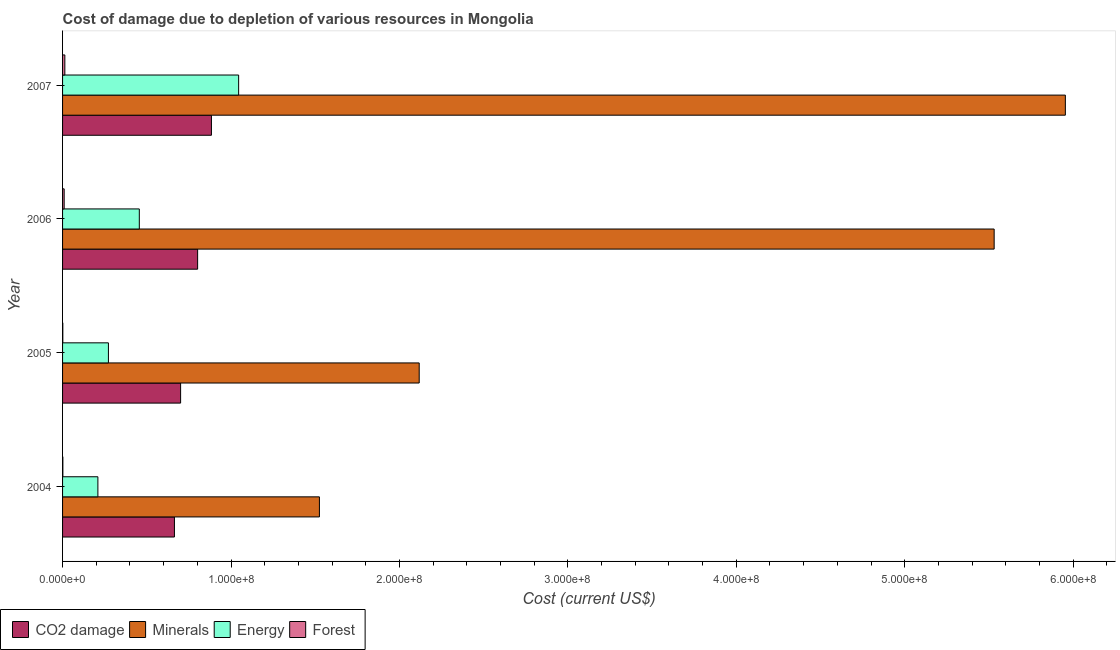How many different coloured bars are there?
Give a very brief answer. 4. Are the number of bars per tick equal to the number of legend labels?
Your response must be concise. Yes. Are the number of bars on each tick of the Y-axis equal?
Ensure brevity in your answer.  Yes. What is the cost of damage due to depletion of energy in 2004?
Provide a short and direct response. 2.10e+07. Across all years, what is the maximum cost of damage due to depletion of coal?
Provide a succinct answer. 8.84e+07. Across all years, what is the minimum cost of damage due to depletion of coal?
Provide a succinct answer. 6.64e+07. In which year was the cost of damage due to depletion of coal minimum?
Ensure brevity in your answer.  2004. What is the total cost of damage due to depletion of energy in the graph?
Offer a very short reply. 1.98e+08. What is the difference between the cost of damage due to depletion of minerals in 2005 and that in 2007?
Make the answer very short. -3.84e+08. What is the difference between the cost of damage due to depletion of minerals in 2007 and the cost of damage due to depletion of energy in 2006?
Your answer should be very brief. 5.50e+08. What is the average cost of damage due to depletion of coal per year?
Your answer should be compact. 7.63e+07. In the year 2004, what is the difference between the cost of damage due to depletion of energy and cost of damage due to depletion of minerals?
Give a very brief answer. -1.32e+08. In how many years, is the cost of damage due to depletion of minerals greater than 320000000 US$?
Make the answer very short. 2. What is the ratio of the cost of damage due to depletion of forests in 2004 to that in 2006?
Give a very brief answer. 0.19. Is the cost of damage due to depletion of forests in 2004 less than that in 2005?
Keep it short and to the point. No. Is the difference between the cost of damage due to depletion of minerals in 2004 and 2007 greater than the difference between the cost of damage due to depletion of energy in 2004 and 2007?
Give a very brief answer. No. What is the difference between the highest and the second highest cost of damage due to depletion of coal?
Provide a succinct answer. 8.20e+06. What is the difference between the highest and the lowest cost of damage due to depletion of energy?
Your answer should be very brief. 8.36e+07. In how many years, is the cost of damage due to depletion of energy greater than the average cost of damage due to depletion of energy taken over all years?
Offer a terse response. 1. What does the 3rd bar from the top in 2007 represents?
Ensure brevity in your answer.  Minerals. What does the 3rd bar from the bottom in 2005 represents?
Your answer should be very brief. Energy. How many years are there in the graph?
Offer a terse response. 4. Does the graph contain any zero values?
Your answer should be very brief. No. Where does the legend appear in the graph?
Your answer should be compact. Bottom left. How many legend labels are there?
Your response must be concise. 4. What is the title of the graph?
Provide a succinct answer. Cost of damage due to depletion of various resources in Mongolia . Does "Coal" appear as one of the legend labels in the graph?
Your answer should be compact. No. What is the label or title of the X-axis?
Keep it short and to the point. Cost (current US$). What is the Cost (current US$) of CO2 damage in 2004?
Offer a very short reply. 6.64e+07. What is the Cost (current US$) of Minerals in 2004?
Offer a very short reply. 1.53e+08. What is the Cost (current US$) of Energy in 2004?
Keep it short and to the point. 2.10e+07. What is the Cost (current US$) of Forest in 2004?
Keep it short and to the point. 1.76e+05. What is the Cost (current US$) in CO2 damage in 2005?
Ensure brevity in your answer.  7.01e+07. What is the Cost (current US$) of Minerals in 2005?
Give a very brief answer. 2.12e+08. What is the Cost (current US$) in Energy in 2005?
Your answer should be very brief. 2.72e+07. What is the Cost (current US$) of Forest in 2005?
Keep it short and to the point. 1.45e+05. What is the Cost (current US$) of CO2 damage in 2006?
Provide a succinct answer. 8.02e+07. What is the Cost (current US$) in Minerals in 2006?
Provide a short and direct response. 5.53e+08. What is the Cost (current US$) in Energy in 2006?
Provide a short and direct response. 4.56e+07. What is the Cost (current US$) in Forest in 2006?
Provide a short and direct response. 9.49e+05. What is the Cost (current US$) of CO2 damage in 2007?
Provide a short and direct response. 8.84e+07. What is the Cost (current US$) in Minerals in 2007?
Make the answer very short. 5.95e+08. What is the Cost (current US$) in Energy in 2007?
Make the answer very short. 1.05e+08. What is the Cost (current US$) in Forest in 2007?
Keep it short and to the point. 1.35e+06. Across all years, what is the maximum Cost (current US$) of CO2 damage?
Your response must be concise. 8.84e+07. Across all years, what is the maximum Cost (current US$) of Minerals?
Provide a succinct answer. 5.95e+08. Across all years, what is the maximum Cost (current US$) of Energy?
Provide a short and direct response. 1.05e+08. Across all years, what is the maximum Cost (current US$) of Forest?
Your response must be concise. 1.35e+06. Across all years, what is the minimum Cost (current US$) of CO2 damage?
Your answer should be compact. 6.64e+07. Across all years, what is the minimum Cost (current US$) of Minerals?
Ensure brevity in your answer.  1.53e+08. Across all years, what is the minimum Cost (current US$) in Energy?
Ensure brevity in your answer.  2.10e+07. Across all years, what is the minimum Cost (current US$) of Forest?
Keep it short and to the point. 1.45e+05. What is the total Cost (current US$) in CO2 damage in the graph?
Make the answer very short. 3.05e+08. What is the total Cost (current US$) in Minerals in the graph?
Offer a terse response. 1.51e+09. What is the total Cost (current US$) in Energy in the graph?
Give a very brief answer. 1.98e+08. What is the total Cost (current US$) in Forest in the graph?
Provide a short and direct response. 2.62e+06. What is the difference between the Cost (current US$) of CO2 damage in 2004 and that in 2005?
Ensure brevity in your answer.  -3.67e+06. What is the difference between the Cost (current US$) in Minerals in 2004 and that in 2005?
Offer a very short reply. -5.92e+07. What is the difference between the Cost (current US$) in Energy in 2004 and that in 2005?
Your answer should be very brief. -6.25e+06. What is the difference between the Cost (current US$) of Forest in 2004 and that in 2005?
Ensure brevity in your answer.  3.19e+04. What is the difference between the Cost (current US$) in CO2 damage in 2004 and that in 2006?
Keep it short and to the point. -1.38e+07. What is the difference between the Cost (current US$) in Minerals in 2004 and that in 2006?
Ensure brevity in your answer.  -4.01e+08. What is the difference between the Cost (current US$) in Energy in 2004 and that in 2006?
Your response must be concise. -2.46e+07. What is the difference between the Cost (current US$) in Forest in 2004 and that in 2006?
Keep it short and to the point. -7.73e+05. What is the difference between the Cost (current US$) of CO2 damage in 2004 and that in 2007?
Give a very brief answer. -2.20e+07. What is the difference between the Cost (current US$) in Minerals in 2004 and that in 2007?
Provide a short and direct response. -4.43e+08. What is the difference between the Cost (current US$) in Energy in 2004 and that in 2007?
Ensure brevity in your answer.  -8.36e+07. What is the difference between the Cost (current US$) of Forest in 2004 and that in 2007?
Your response must be concise. -1.18e+06. What is the difference between the Cost (current US$) in CO2 damage in 2005 and that in 2006?
Ensure brevity in your answer.  -1.01e+07. What is the difference between the Cost (current US$) of Minerals in 2005 and that in 2006?
Your answer should be very brief. -3.41e+08. What is the difference between the Cost (current US$) in Energy in 2005 and that in 2006?
Provide a short and direct response. -1.83e+07. What is the difference between the Cost (current US$) in Forest in 2005 and that in 2006?
Give a very brief answer. -8.05e+05. What is the difference between the Cost (current US$) of CO2 damage in 2005 and that in 2007?
Provide a succinct answer. -1.83e+07. What is the difference between the Cost (current US$) in Minerals in 2005 and that in 2007?
Provide a short and direct response. -3.84e+08. What is the difference between the Cost (current US$) in Energy in 2005 and that in 2007?
Keep it short and to the point. -7.73e+07. What is the difference between the Cost (current US$) of Forest in 2005 and that in 2007?
Offer a very short reply. -1.21e+06. What is the difference between the Cost (current US$) of CO2 damage in 2006 and that in 2007?
Ensure brevity in your answer.  -8.20e+06. What is the difference between the Cost (current US$) of Minerals in 2006 and that in 2007?
Offer a very short reply. -4.23e+07. What is the difference between the Cost (current US$) of Energy in 2006 and that in 2007?
Provide a short and direct response. -5.90e+07. What is the difference between the Cost (current US$) of Forest in 2006 and that in 2007?
Provide a succinct answer. -4.04e+05. What is the difference between the Cost (current US$) in CO2 damage in 2004 and the Cost (current US$) in Minerals in 2005?
Offer a very short reply. -1.45e+08. What is the difference between the Cost (current US$) of CO2 damage in 2004 and the Cost (current US$) of Energy in 2005?
Provide a short and direct response. 3.92e+07. What is the difference between the Cost (current US$) of CO2 damage in 2004 and the Cost (current US$) of Forest in 2005?
Ensure brevity in your answer.  6.63e+07. What is the difference between the Cost (current US$) of Minerals in 2004 and the Cost (current US$) of Energy in 2005?
Offer a very short reply. 1.25e+08. What is the difference between the Cost (current US$) of Minerals in 2004 and the Cost (current US$) of Forest in 2005?
Make the answer very short. 1.52e+08. What is the difference between the Cost (current US$) in Energy in 2004 and the Cost (current US$) in Forest in 2005?
Ensure brevity in your answer.  2.08e+07. What is the difference between the Cost (current US$) in CO2 damage in 2004 and the Cost (current US$) in Minerals in 2006?
Your response must be concise. -4.87e+08. What is the difference between the Cost (current US$) of CO2 damage in 2004 and the Cost (current US$) of Energy in 2006?
Ensure brevity in your answer.  2.08e+07. What is the difference between the Cost (current US$) in CO2 damage in 2004 and the Cost (current US$) in Forest in 2006?
Provide a succinct answer. 6.55e+07. What is the difference between the Cost (current US$) of Minerals in 2004 and the Cost (current US$) of Energy in 2006?
Offer a terse response. 1.07e+08. What is the difference between the Cost (current US$) of Minerals in 2004 and the Cost (current US$) of Forest in 2006?
Your answer should be very brief. 1.52e+08. What is the difference between the Cost (current US$) of Energy in 2004 and the Cost (current US$) of Forest in 2006?
Your answer should be compact. 2.00e+07. What is the difference between the Cost (current US$) of CO2 damage in 2004 and the Cost (current US$) of Minerals in 2007?
Offer a terse response. -5.29e+08. What is the difference between the Cost (current US$) in CO2 damage in 2004 and the Cost (current US$) in Energy in 2007?
Provide a short and direct response. -3.81e+07. What is the difference between the Cost (current US$) of CO2 damage in 2004 and the Cost (current US$) of Forest in 2007?
Ensure brevity in your answer.  6.51e+07. What is the difference between the Cost (current US$) in Minerals in 2004 and the Cost (current US$) in Energy in 2007?
Offer a terse response. 4.80e+07. What is the difference between the Cost (current US$) in Minerals in 2004 and the Cost (current US$) in Forest in 2007?
Keep it short and to the point. 1.51e+08. What is the difference between the Cost (current US$) of Energy in 2004 and the Cost (current US$) of Forest in 2007?
Provide a succinct answer. 1.96e+07. What is the difference between the Cost (current US$) of CO2 damage in 2005 and the Cost (current US$) of Minerals in 2006?
Your answer should be very brief. -4.83e+08. What is the difference between the Cost (current US$) in CO2 damage in 2005 and the Cost (current US$) in Energy in 2006?
Make the answer very short. 2.45e+07. What is the difference between the Cost (current US$) in CO2 damage in 2005 and the Cost (current US$) in Forest in 2006?
Ensure brevity in your answer.  6.91e+07. What is the difference between the Cost (current US$) of Minerals in 2005 and the Cost (current US$) of Energy in 2006?
Make the answer very short. 1.66e+08. What is the difference between the Cost (current US$) in Minerals in 2005 and the Cost (current US$) in Forest in 2006?
Provide a succinct answer. 2.11e+08. What is the difference between the Cost (current US$) of Energy in 2005 and the Cost (current US$) of Forest in 2006?
Provide a succinct answer. 2.63e+07. What is the difference between the Cost (current US$) of CO2 damage in 2005 and the Cost (current US$) of Minerals in 2007?
Give a very brief answer. -5.25e+08. What is the difference between the Cost (current US$) of CO2 damage in 2005 and the Cost (current US$) of Energy in 2007?
Provide a short and direct response. -3.44e+07. What is the difference between the Cost (current US$) of CO2 damage in 2005 and the Cost (current US$) of Forest in 2007?
Your answer should be compact. 6.87e+07. What is the difference between the Cost (current US$) of Minerals in 2005 and the Cost (current US$) of Energy in 2007?
Offer a very short reply. 1.07e+08. What is the difference between the Cost (current US$) in Minerals in 2005 and the Cost (current US$) in Forest in 2007?
Offer a terse response. 2.10e+08. What is the difference between the Cost (current US$) of Energy in 2005 and the Cost (current US$) of Forest in 2007?
Keep it short and to the point. 2.59e+07. What is the difference between the Cost (current US$) of CO2 damage in 2006 and the Cost (current US$) of Minerals in 2007?
Provide a succinct answer. -5.15e+08. What is the difference between the Cost (current US$) in CO2 damage in 2006 and the Cost (current US$) in Energy in 2007?
Provide a short and direct response. -2.44e+07. What is the difference between the Cost (current US$) of CO2 damage in 2006 and the Cost (current US$) of Forest in 2007?
Offer a terse response. 7.88e+07. What is the difference between the Cost (current US$) in Minerals in 2006 and the Cost (current US$) in Energy in 2007?
Keep it short and to the point. 4.49e+08. What is the difference between the Cost (current US$) in Minerals in 2006 and the Cost (current US$) in Forest in 2007?
Provide a succinct answer. 5.52e+08. What is the difference between the Cost (current US$) of Energy in 2006 and the Cost (current US$) of Forest in 2007?
Provide a succinct answer. 4.42e+07. What is the average Cost (current US$) of CO2 damage per year?
Offer a terse response. 7.63e+07. What is the average Cost (current US$) in Minerals per year?
Keep it short and to the point. 3.78e+08. What is the average Cost (current US$) in Energy per year?
Make the answer very short. 4.96e+07. What is the average Cost (current US$) of Forest per year?
Provide a succinct answer. 6.56e+05. In the year 2004, what is the difference between the Cost (current US$) of CO2 damage and Cost (current US$) of Minerals?
Give a very brief answer. -8.61e+07. In the year 2004, what is the difference between the Cost (current US$) of CO2 damage and Cost (current US$) of Energy?
Ensure brevity in your answer.  4.54e+07. In the year 2004, what is the difference between the Cost (current US$) of CO2 damage and Cost (current US$) of Forest?
Ensure brevity in your answer.  6.62e+07. In the year 2004, what is the difference between the Cost (current US$) in Minerals and Cost (current US$) in Energy?
Make the answer very short. 1.32e+08. In the year 2004, what is the difference between the Cost (current US$) of Minerals and Cost (current US$) of Forest?
Provide a short and direct response. 1.52e+08. In the year 2004, what is the difference between the Cost (current US$) of Energy and Cost (current US$) of Forest?
Offer a terse response. 2.08e+07. In the year 2005, what is the difference between the Cost (current US$) of CO2 damage and Cost (current US$) of Minerals?
Ensure brevity in your answer.  -1.42e+08. In the year 2005, what is the difference between the Cost (current US$) in CO2 damage and Cost (current US$) in Energy?
Give a very brief answer. 4.29e+07. In the year 2005, what is the difference between the Cost (current US$) in CO2 damage and Cost (current US$) in Forest?
Provide a succinct answer. 6.99e+07. In the year 2005, what is the difference between the Cost (current US$) of Minerals and Cost (current US$) of Energy?
Your answer should be very brief. 1.85e+08. In the year 2005, what is the difference between the Cost (current US$) of Minerals and Cost (current US$) of Forest?
Provide a succinct answer. 2.12e+08. In the year 2005, what is the difference between the Cost (current US$) in Energy and Cost (current US$) in Forest?
Your answer should be very brief. 2.71e+07. In the year 2006, what is the difference between the Cost (current US$) of CO2 damage and Cost (current US$) of Minerals?
Provide a short and direct response. -4.73e+08. In the year 2006, what is the difference between the Cost (current US$) in CO2 damage and Cost (current US$) in Energy?
Give a very brief answer. 3.46e+07. In the year 2006, what is the difference between the Cost (current US$) in CO2 damage and Cost (current US$) in Forest?
Ensure brevity in your answer.  7.92e+07. In the year 2006, what is the difference between the Cost (current US$) in Minerals and Cost (current US$) in Energy?
Provide a succinct answer. 5.08e+08. In the year 2006, what is the difference between the Cost (current US$) in Minerals and Cost (current US$) in Forest?
Offer a very short reply. 5.52e+08. In the year 2006, what is the difference between the Cost (current US$) of Energy and Cost (current US$) of Forest?
Keep it short and to the point. 4.46e+07. In the year 2007, what is the difference between the Cost (current US$) in CO2 damage and Cost (current US$) in Minerals?
Your answer should be very brief. -5.07e+08. In the year 2007, what is the difference between the Cost (current US$) of CO2 damage and Cost (current US$) of Energy?
Your answer should be very brief. -1.62e+07. In the year 2007, what is the difference between the Cost (current US$) of CO2 damage and Cost (current US$) of Forest?
Offer a terse response. 8.70e+07. In the year 2007, what is the difference between the Cost (current US$) of Minerals and Cost (current US$) of Energy?
Offer a very short reply. 4.91e+08. In the year 2007, what is the difference between the Cost (current US$) of Minerals and Cost (current US$) of Forest?
Your answer should be compact. 5.94e+08. In the year 2007, what is the difference between the Cost (current US$) in Energy and Cost (current US$) in Forest?
Give a very brief answer. 1.03e+08. What is the ratio of the Cost (current US$) in CO2 damage in 2004 to that in 2005?
Provide a short and direct response. 0.95. What is the ratio of the Cost (current US$) in Minerals in 2004 to that in 2005?
Ensure brevity in your answer.  0.72. What is the ratio of the Cost (current US$) of Energy in 2004 to that in 2005?
Keep it short and to the point. 0.77. What is the ratio of the Cost (current US$) of Forest in 2004 to that in 2005?
Provide a succinct answer. 1.22. What is the ratio of the Cost (current US$) in CO2 damage in 2004 to that in 2006?
Your answer should be very brief. 0.83. What is the ratio of the Cost (current US$) of Minerals in 2004 to that in 2006?
Provide a succinct answer. 0.28. What is the ratio of the Cost (current US$) of Energy in 2004 to that in 2006?
Keep it short and to the point. 0.46. What is the ratio of the Cost (current US$) in Forest in 2004 to that in 2006?
Your answer should be compact. 0.19. What is the ratio of the Cost (current US$) of CO2 damage in 2004 to that in 2007?
Offer a terse response. 0.75. What is the ratio of the Cost (current US$) of Minerals in 2004 to that in 2007?
Your answer should be compact. 0.26. What is the ratio of the Cost (current US$) in Energy in 2004 to that in 2007?
Keep it short and to the point. 0.2. What is the ratio of the Cost (current US$) in Forest in 2004 to that in 2007?
Make the answer very short. 0.13. What is the ratio of the Cost (current US$) in CO2 damage in 2005 to that in 2006?
Give a very brief answer. 0.87. What is the ratio of the Cost (current US$) of Minerals in 2005 to that in 2006?
Provide a short and direct response. 0.38. What is the ratio of the Cost (current US$) in Energy in 2005 to that in 2006?
Provide a succinct answer. 0.6. What is the ratio of the Cost (current US$) in Forest in 2005 to that in 2006?
Your answer should be compact. 0.15. What is the ratio of the Cost (current US$) of CO2 damage in 2005 to that in 2007?
Your response must be concise. 0.79. What is the ratio of the Cost (current US$) of Minerals in 2005 to that in 2007?
Keep it short and to the point. 0.36. What is the ratio of the Cost (current US$) in Energy in 2005 to that in 2007?
Offer a very short reply. 0.26. What is the ratio of the Cost (current US$) in Forest in 2005 to that in 2007?
Provide a short and direct response. 0.11. What is the ratio of the Cost (current US$) in CO2 damage in 2006 to that in 2007?
Make the answer very short. 0.91. What is the ratio of the Cost (current US$) of Minerals in 2006 to that in 2007?
Your response must be concise. 0.93. What is the ratio of the Cost (current US$) of Energy in 2006 to that in 2007?
Provide a succinct answer. 0.44. What is the ratio of the Cost (current US$) of Forest in 2006 to that in 2007?
Make the answer very short. 0.7. What is the difference between the highest and the second highest Cost (current US$) of CO2 damage?
Your answer should be very brief. 8.20e+06. What is the difference between the highest and the second highest Cost (current US$) of Minerals?
Offer a very short reply. 4.23e+07. What is the difference between the highest and the second highest Cost (current US$) in Energy?
Ensure brevity in your answer.  5.90e+07. What is the difference between the highest and the second highest Cost (current US$) in Forest?
Provide a short and direct response. 4.04e+05. What is the difference between the highest and the lowest Cost (current US$) in CO2 damage?
Ensure brevity in your answer.  2.20e+07. What is the difference between the highest and the lowest Cost (current US$) of Minerals?
Ensure brevity in your answer.  4.43e+08. What is the difference between the highest and the lowest Cost (current US$) of Energy?
Your answer should be compact. 8.36e+07. What is the difference between the highest and the lowest Cost (current US$) of Forest?
Offer a terse response. 1.21e+06. 